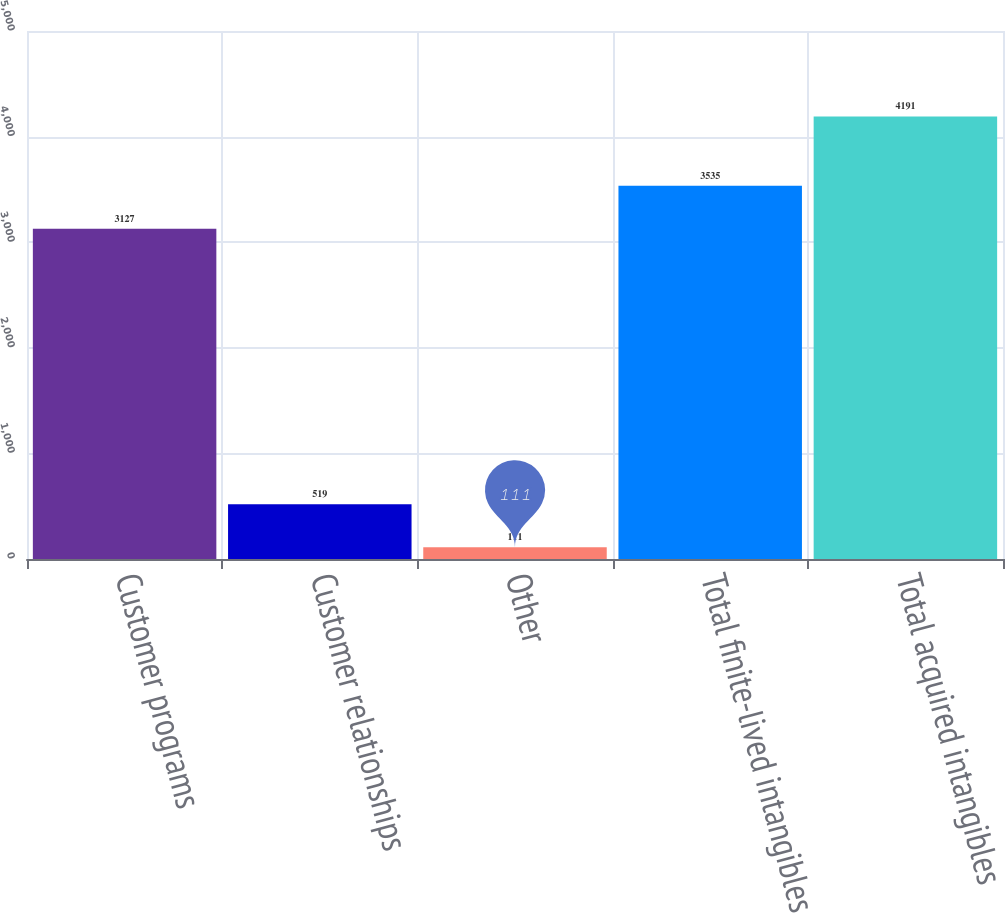Convert chart to OTSL. <chart><loc_0><loc_0><loc_500><loc_500><bar_chart><fcel>Customer programs<fcel>Customer relationships<fcel>Other<fcel>Total finite-lived intangibles<fcel>Total acquired intangibles<nl><fcel>3127<fcel>519<fcel>111<fcel>3535<fcel>4191<nl></chart> 